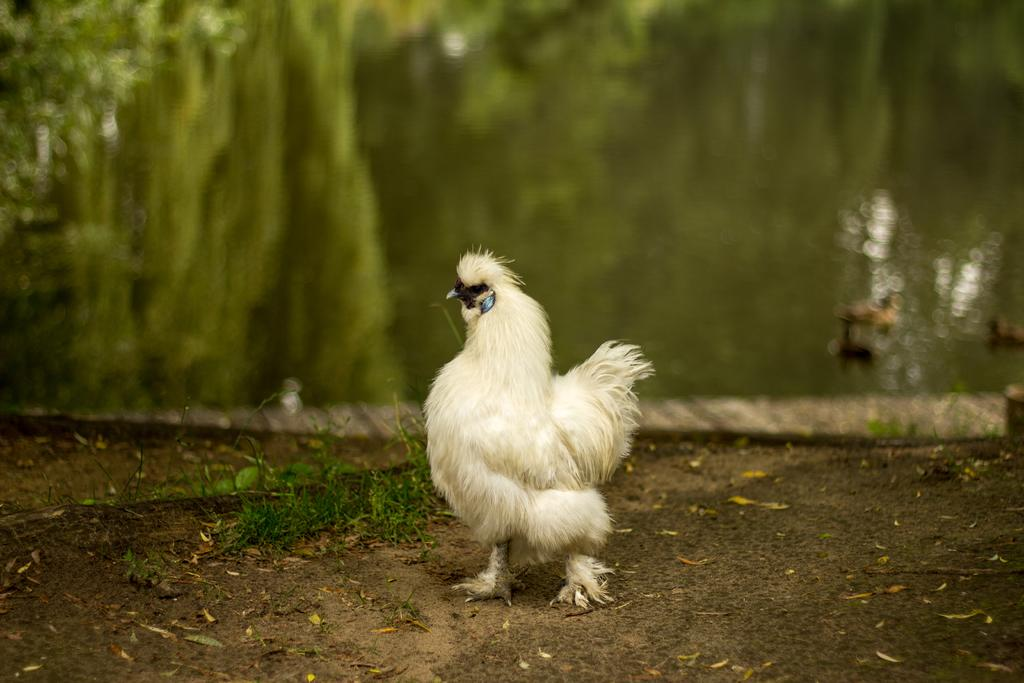What animal is present in the image? There is a hen in the image. What type of terrain is visible in the image? There is grass on the ground in the image. What can be seen in the background of the image? There is water visible in the background of the image. How many feet does the hen have in the image? The number of feet the hen has cannot be determined from the image alone, as it is a two-dimensional representation. However, hens typically have two legs with a total of four feet. 